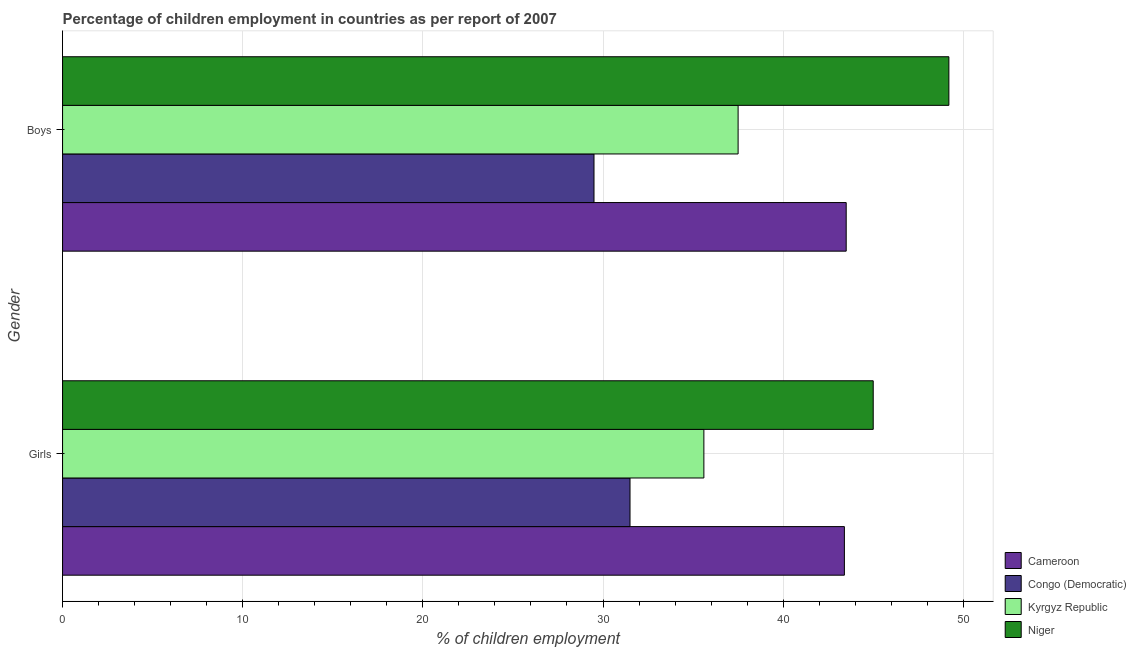Are the number of bars on each tick of the Y-axis equal?
Your response must be concise. Yes. What is the label of the 2nd group of bars from the top?
Keep it short and to the point. Girls. What is the percentage of employed girls in Niger?
Offer a terse response. 45. Across all countries, what is the maximum percentage of employed boys?
Your answer should be very brief. 49.2. Across all countries, what is the minimum percentage of employed boys?
Your answer should be very brief. 29.5. In which country was the percentage of employed girls maximum?
Keep it short and to the point. Niger. In which country was the percentage of employed girls minimum?
Your response must be concise. Congo (Democratic). What is the total percentage of employed boys in the graph?
Provide a short and direct response. 159.7. What is the difference between the percentage of employed girls in Cameroon and that in Kyrgyz Republic?
Offer a terse response. 7.8. What is the difference between the percentage of employed girls in Kyrgyz Republic and the percentage of employed boys in Congo (Democratic)?
Give a very brief answer. 6.1. What is the average percentage of employed girls per country?
Give a very brief answer. 38.88. What is the ratio of the percentage of employed girls in Congo (Democratic) to that in Kyrgyz Republic?
Your response must be concise. 0.88. What does the 2nd bar from the top in Boys represents?
Provide a short and direct response. Kyrgyz Republic. What does the 4th bar from the bottom in Girls represents?
Your answer should be compact. Niger. How many bars are there?
Your answer should be very brief. 8. Are all the bars in the graph horizontal?
Give a very brief answer. Yes. How many countries are there in the graph?
Your answer should be very brief. 4. What is the difference between two consecutive major ticks on the X-axis?
Your answer should be very brief. 10. Are the values on the major ticks of X-axis written in scientific E-notation?
Your response must be concise. No. Does the graph contain grids?
Keep it short and to the point. Yes. How many legend labels are there?
Offer a terse response. 4. How are the legend labels stacked?
Your response must be concise. Vertical. What is the title of the graph?
Provide a succinct answer. Percentage of children employment in countries as per report of 2007. Does "Estonia" appear as one of the legend labels in the graph?
Provide a short and direct response. No. What is the label or title of the X-axis?
Provide a short and direct response. % of children employment. What is the label or title of the Y-axis?
Your answer should be very brief. Gender. What is the % of children employment in Cameroon in Girls?
Provide a succinct answer. 43.4. What is the % of children employment in Congo (Democratic) in Girls?
Give a very brief answer. 31.5. What is the % of children employment in Kyrgyz Republic in Girls?
Provide a succinct answer. 35.6. What is the % of children employment in Niger in Girls?
Your answer should be compact. 45. What is the % of children employment in Cameroon in Boys?
Your response must be concise. 43.5. What is the % of children employment of Congo (Democratic) in Boys?
Your response must be concise. 29.5. What is the % of children employment in Kyrgyz Republic in Boys?
Give a very brief answer. 37.5. What is the % of children employment of Niger in Boys?
Your answer should be compact. 49.2. Across all Gender, what is the maximum % of children employment in Cameroon?
Give a very brief answer. 43.5. Across all Gender, what is the maximum % of children employment of Congo (Democratic)?
Provide a succinct answer. 31.5. Across all Gender, what is the maximum % of children employment in Kyrgyz Republic?
Make the answer very short. 37.5. Across all Gender, what is the maximum % of children employment in Niger?
Provide a short and direct response. 49.2. Across all Gender, what is the minimum % of children employment in Cameroon?
Offer a terse response. 43.4. Across all Gender, what is the minimum % of children employment of Congo (Democratic)?
Keep it short and to the point. 29.5. Across all Gender, what is the minimum % of children employment in Kyrgyz Republic?
Offer a terse response. 35.6. Across all Gender, what is the minimum % of children employment in Niger?
Provide a short and direct response. 45. What is the total % of children employment of Cameroon in the graph?
Your answer should be very brief. 86.9. What is the total % of children employment in Kyrgyz Republic in the graph?
Keep it short and to the point. 73.1. What is the total % of children employment in Niger in the graph?
Your answer should be very brief. 94.2. What is the difference between the % of children employment in Congo (Democratic) in Girls and that in Boys?
Offer a terse response. 2. What is the difference between the % of children employment in Kyrgyz Republic in Girls and that in Boys?
Offer a very short reply. -1.9. What is the difference between the % of children employment of Niger in Girls and that in Boys?
Keep it short and to the point. -4.2. What is the difference between the % of children employment in Cameroon in Girls and the % of children employment in Congo (Democratic) in Boys?
Your answer should be compact. 13.9. What is the difference between the % of children employment of Cameroon in Girls and the % of children employment of Niger in Boys?
Your answer should be compact. -5.8. What is the difference between the % of children employment of Congo (Democratic) in Girls and the % of children employment of Kyrgyz Republic in Boys?
Ensure brevity in your answer.  -6. What is the difference between the % of children employment of Congo (Democratic) in Girls and the % of children employment of Niger in Boys?
Ensure brevity in your answer.  -17.7. What is the difference between the % of children employment in Kyrgyz Republic in Girls and the % of children employment in Niger in Boys?
Your answer should be compact. -13.6. What is the average % of children employment in Cameroon per Gender?
Your answer should be very brief. 43.45. What is the average % of children employment of Congo (Democratic) per Gender?
Offer a terse response. 30.5. What is the average % of children employment of Kyrgyz Republic per Gender?
Your answer should be very brief. 36.55. What is the average % of children employment in Niger per Gender?
Offer a terse response. 47.1. What is the difference between the % of children employment in Cameroon and % of children employment in Congo (Democratic) in Girls?
Provide a short and direct response. 11.9. What is the difference between the % of children employment of Congo (Democratic) and % of children employment of Kyrgyz Republic in Girls?
Give a very brief answer. -4.1. What is the difference between the % of children employment in Congo (Democratic) and % of children employment in Niger in Girls?
Your answer should be compact. -13.5. What is the difference between the % of children employment in Cameroon and % of children employment in Niger in Boys?
Your response must be concise. -5.7. What is the difference between the % of children employment in Congo (Democratic) and % of children employment in Kyrgyz Republic in Boys?
Offer a terse response. -8. What is the difference between the % of children employment in Congo (Democratic) and % of children employment in Niger in Boys?
Provide a succinct answer. -19.7. What is the ratio of the % of children employment of Cameroon in Girls to that in Boys?
Your answer should be very brief. 1. What is the ratio of the % of children employment of Congo (Democratic) in Girls to that in Boys?
Give a very brief answer. 1.07. What is the ratio of the % of children employment in Kyrgyz Republic in Girls to that in Boys?
Offer a very short reply. 0.95. What is the ratio of the % of children employment in Niger in Girls to that in Boys?
Offer a terse response. 0.91. What is the difference between the highest and the second highest % of children employment in Cameroon?
Give a very brief answer. 0.1. What is the difference between the highest and the second highest % of children employment of Congo (Democratic)?
Provide a succinct answer. 2. What is the difference between the highest and the second highest % of children employment of Kyrgyz Republic?
Make the answer very short. 1.9. What is the difference between the highest and the lowest % of children employment of Cameroon?
Your response must be concise. 0.1. What is the difference between the highest and the lowest % of children employment of Congo (Democratic)?
Provide a succinct answer. 2. What is the difference between the highest and the lowest % of children employment of Kyrgyz Republic?
Make the answer very short. 1.9. What is the difference between the highest and the lowest % of children employment of Niger?
Make the answer very short. 4.2. 